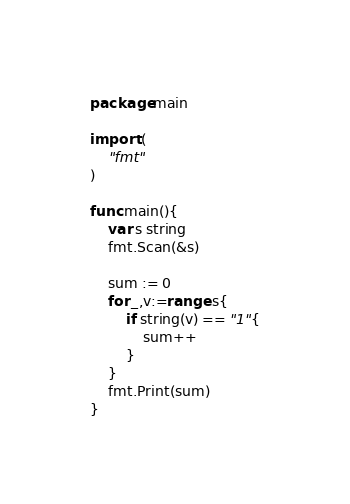Convert code to text. <code><loc_0><loc_0><loc_500><loc_500><_Go_>package main

import (
	"fmt"
)

func main(){
	var s string
	fmt.Scan(&s)

	sum := 0
	for _,v:=range s{
		if string(v) == "1"{
			sum++
		}
	}
	fmt.Print(sum)
}</code> 